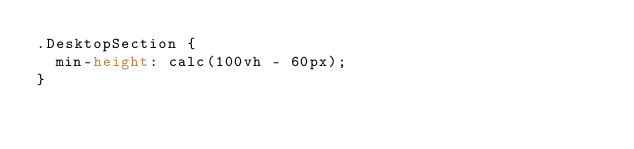<code> <loc_0><loc_0><loc_500><loc_500><_CSS_>.DesktopSection {
  min-height: calc(100vh - 60px);
}
</code> 